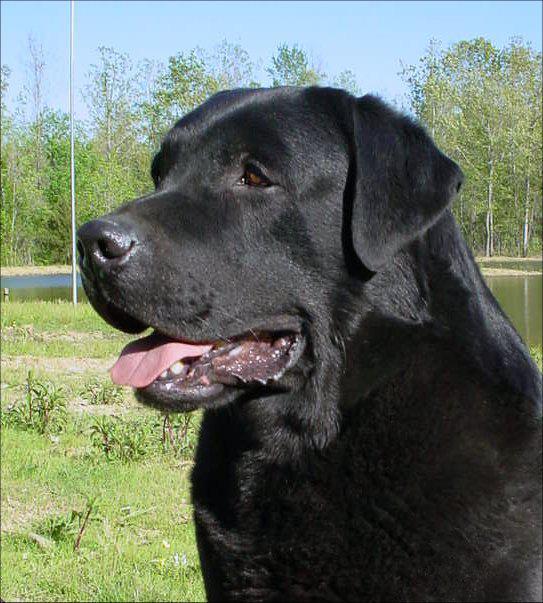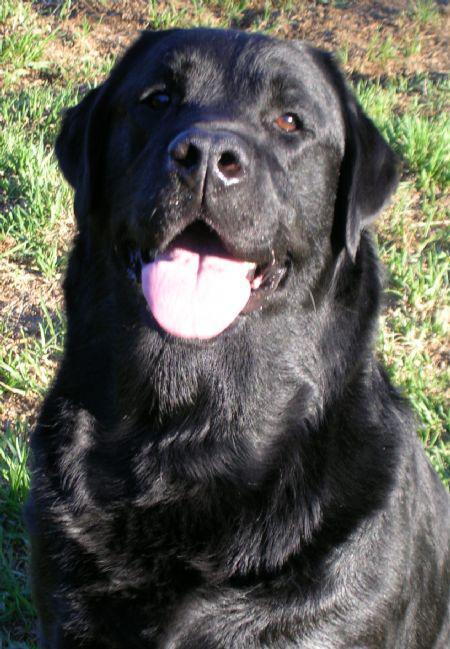The first image is the image on the left, the second image is the image on the right. Given the left and right images, does the statement "A large brown colored dog is outside." hold true? Answer yes or no. No. The first image is the image on the left, the second image is the image on the right. For the images displayed, is the sentence "One of the images shows a black labrador and the other shows a brown labrador." factually correct? Answer yes or no. No. 